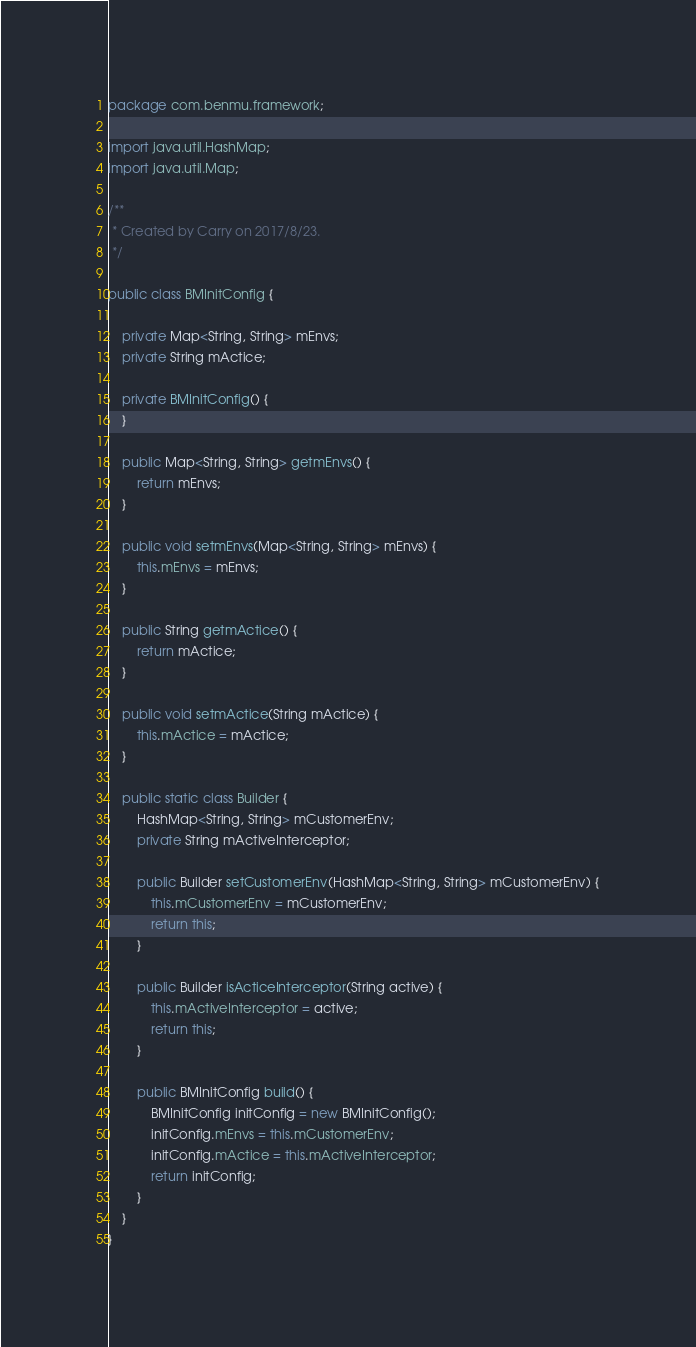<code> <loc_0><loc_0><loc_500><loc_500><_Java_>package com.benmu.framework;

import java.util.HashMap;
import java.util.Map;

/**
 * Created by Carry on 2017/8/23.
 */

public class BMInitConfig {

    private Map<String, String> mEnvs;
    private String mActice;

    private BMInitConfig() {
    }

    public Map<String, String> getmEnvs() {
        return mEnvs;
    }

    public void setmEnvs(Map<String, String> mEnvs) {
        this.mEnvs = mEnvs;
    }

    public String getmActice() {
        return mActice;
    }

    public void setmActice(String mActice) {
        this.mActice = mActice;
    }

    public static class Builder {
        HashMap<String, String> mCustomerEnv;
        private String mActiveInterceptor;

        public Builder setCustomerEnv(HashMap<String, String> mCustomerEnv) {
            this.mCustomerEnv = mCustomerEnv;
            return this;
        }

        public Builder isActiceInterceptor(String active) {
            this.mActiveInterceptor = active;
            return this;
        }

        public BMInitConfig build() {
            BMInitConfig initConfig = new BMInitConfig();
            initConfig.mEnvs = this.mCustomerEnv;
            initConfig.mActice = this.mActiveInterceptor;
            return initConfig;
        }
    }
}
</code> 